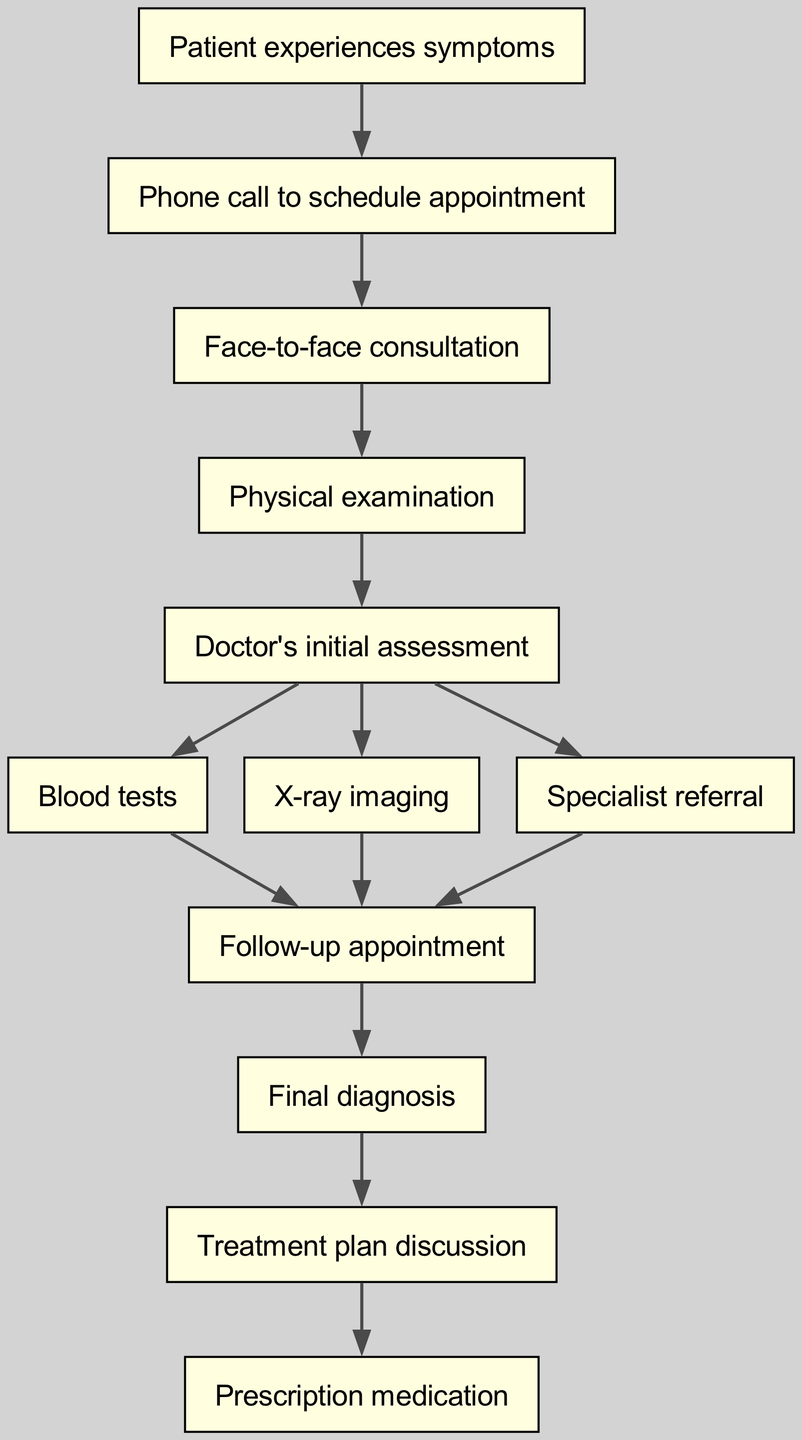What is the first node in the diagram? The first node is "Patient experiences symptoms," which initiates the medical diagnosis process according to the diagram's flow.
Answer: Patient experiences symptoms How many nodes are there in total? The diagram lists 12 distinct nodes, representing the different stages of the medical diagnosis process.
Answer: 12 What is the last step before the prescription? The last step before the prescription is "Treatment plan discussion," which occurs after the final diagnosis has been made, as indicated by the directed edge.
Answer: Treatment plan discussion Which node follows "Final diagnosis"? The node that follows "Final diagnosis" is "Treatment plan discussion," indicating the progression towards treatment after a diagnosis is established.
Answer: Treatment plan discussion What type of examination occurs after the face-to-face consultation? After the face-to-face consultation, a "Physical examination" occurs, as clearly indicated by the directed edge leading from the consultation to this examination step.
Answer: Physical examination How many possible paths lead to the "Follow-up appointment"? There are three possible paths leading to "Follow-up appointment," stemming from "Blood tests," "X-ray imaging," and "Specialist referral," which all connect to this node.
Answer: 3 What happens after a "Doctor's initial assessment"? After a "Doctor's initial assessment," several actions can occur: "Blood tests," "X-ray imaging," and "Specialist referral." All these processes are directly influenced by the initial assessment.
Answer: Blood tests, X-ray imaging, Specialist referral Which node does "Blood tests" lead to? "Blood tests" lead to "Follow-up appointment," indicating that the results from the tests will be reviewed in a follow-up consultation with the doctor.
Answer: Follow-up appointment Which node does "Specialist referral" connect to? "Specialist referral" connects to "Follow-up appointment," indicating that a referral to a specialist will also conclude with a follow-up visit for further evaluation.
Answer: Follow-up appointment 